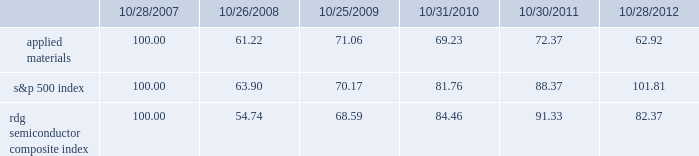Performance graph the performance graph below shows the five-year cumulative total stockholder return on applied common stock during the period from october 28 , 2007 through october 28 , 2012 .
This is compared with the cumulative total return of the standard & poor 2019s 500 stock index and the rdg semiconductor composite index over the same period .
The comparison assumes $ 100 was invested on october 28 , 2007 in applied common stock and in each of the foregoing indices and assumes reinvestment of dividends , if any .
Dollar amounts in the graph are rounded to the nearest whole dollar .
The performance shown in the graph represents past performance and should not be considered an indication of future performance .
Comparison of 5 year cumulative total return* among applied materials , inc. , the s&p 500 index and the rdg semiconductor composite index * $ 100 invested on 10/28/07 in stock or 10/31/07 in index , including reinvestment of dividends .
Indexes calculated on month-end basis .
Copyright a9 2012 s&p , a division of the mcgraw-hill companies inc .
All rights reserved. .
Dividends during fiscal 2012 , applied 2019s board of directors declared three quarterly cash dividends in the amount of $ 0.09 per share each and one quarterly cash dividend in the amount of $ 0.08 per share .
During fiscal 2011 , applied 2019s board of directors declared three quarterly cash dividends in the amount of $ 0.08 per share each and one quarterly cash dividend in the amount of $ 0.07 per share .
During fiscal 2010 , applied 2019s board of directors declared three quarterly cash dividends in the amount of $ 0.07 per share each and one quarterly cash dividend in the amount of $ 0.06 .
Dividends declared during fiscal 2012 , 2011 and 2010 amounted to $ 438 million , $ 408 million and $ 361 million , respectively .
Applied currently anticipates that it will continue to pay cash dividends on a quarterly basis in the future , although the declaration and amount of any future cash dividends are at the discretion of the board of directors and will depend on applied 2019s financial condition , results of operations , capital requirements , business conditions and other factors , as well as a determination that cash dividends are in the best interests of applied 2019s stockholders .
10/28/07 10/26/08 10/25/09 10/31/10 10/30/11 10/28/12 applied materials , inc .
S&p 500 rdg semiconductor composite .
For how many common stock shares did the company pay dividends in 2012 , ( in millions ) ? 
Computations: (438 / ((0.09 * 3) + 0.08))
Answer: 1251.42857. 